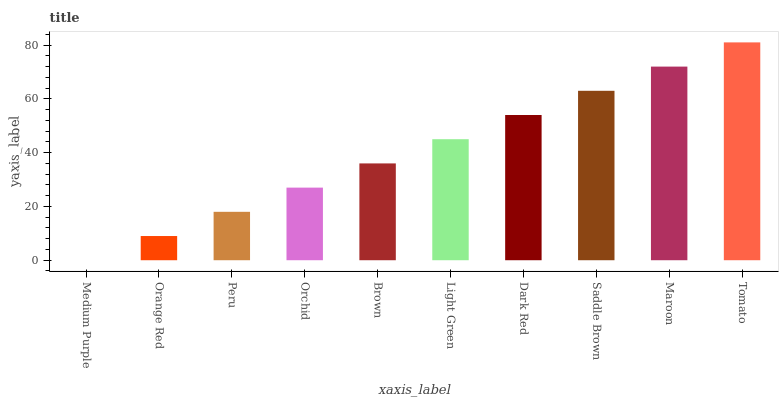Is Medium Purple the minimum?
Answer yes or no. Yes. Is Tomato the maximum?
Answer yes or no. Yes. Is Orange Red the minimum?
Answer yes or no. No. Is Orange Red the maximum?
Answer yes or no. No. Is Orange Red greater than Medium Purple?
Answer yes or no. Yes. Is Medium Purple less than Orange Red?
Answer yes or no. Yes. Is Medium Purple greater than Orange Red?
Answer yes or no. No. Is Orange Red less than Medium Purple?
Answer yes or no. No. Is Light Green the high median?
Answer yes or no. Yes. Is Brown the low median?
Answer yes or no. Yes. Is Orange Red the high median?
Answer yes or no. No. Is Saddle Brown the low median?
Answer yes or no. No. 